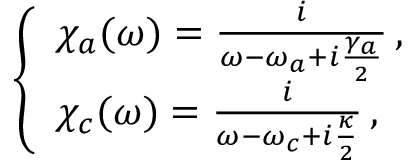<formula> <loc_0><loc_0><loc_500><loc_500>\begin{array} { r } { \left \{ \begin{array} { l l } { \chi _ { a } ( \omega ) = \frac { i } { \omega - \omega _ { a } + i \frac { \gamma _ { a } } { 2 } } \, , } \\ { \chi _ { c } ( \omega ) = \frac { i } { \omega - \omega _ { c } + i \frac { \kappa } { 2 } } \, , } \end{array} \, } \end{array}</formula> 